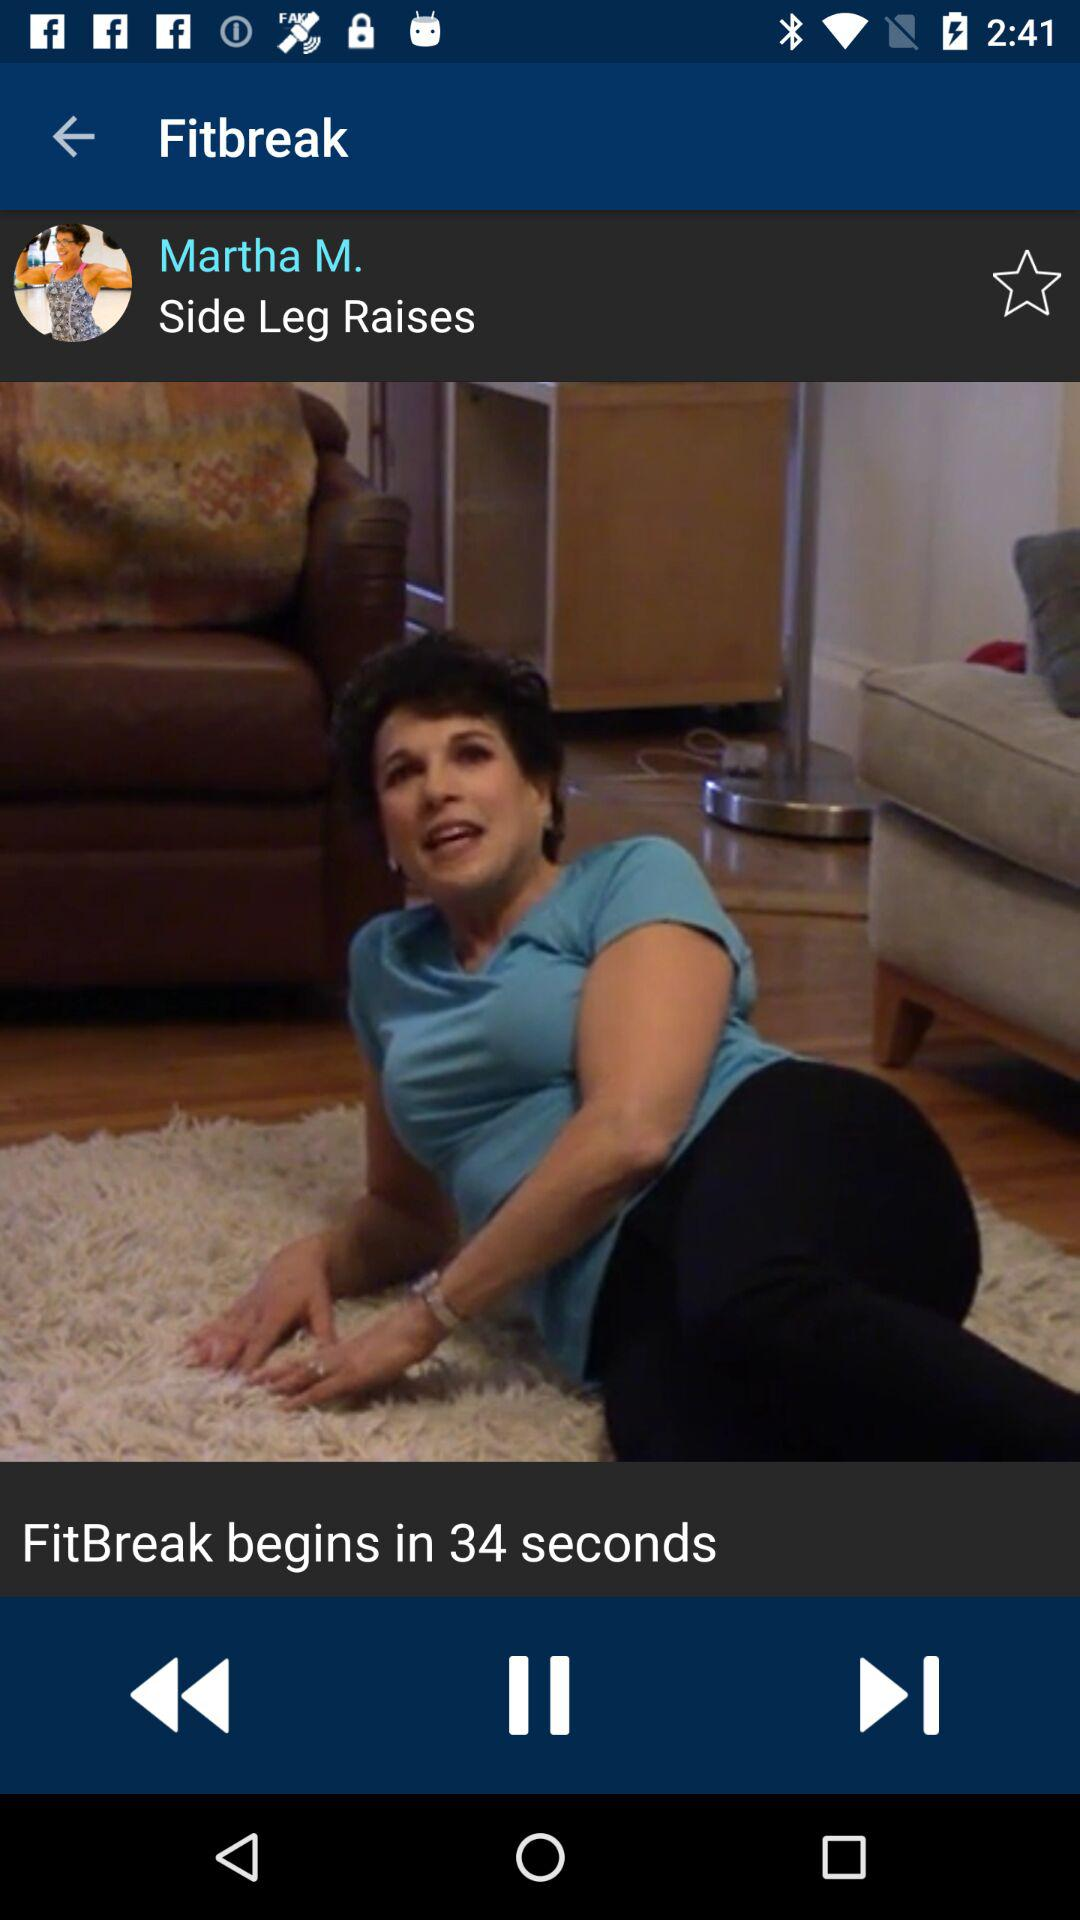How many seconds until the next fitbreak?
Answer the question using a single word or phrase. 34 